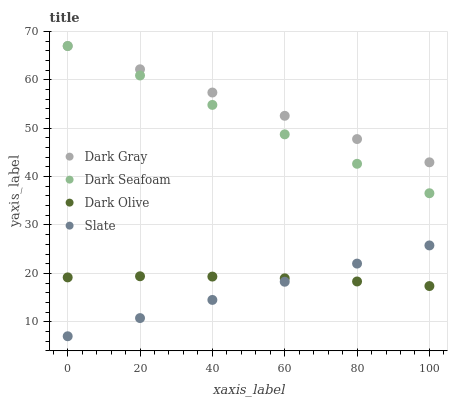Does Slate have the minimum area under the curve?
Answer yes or no. Yes. Does Dark Gray have the maximum area under the curve?
Answer yes or no. Yes. Does Dark Seafoam have the minimum area under the curve?
Answer yes or no. No. Does Dark Seafoam have the maximum area under the curve?
Answer yes or no. No. Is Slate the smoothest?
Answer yes or no. Yes. Is Dark Olive the roughest?
Answer yes or no. Yes. Is Dark Seafoam the smoothest?
Answer yes or no. No. Is Dark Seafoam the roughest?
Answer yes or no. No. Does Slate have the lowest value?
Answer yes or no. Yes. Does Dark Seafoam have the lowest value?
Answer yes or no. No. Does Dark Seafoam have the highest value?
Answer yes or no. Yes. Does Dark Olive have the highest value?
Answer yes or no. No. Is Slate less than Dark Seafoam?
Answer yes or no. Yes. Is Dark Gray greater than Dark Olive?
Answer yes or no. Yes. Does Slate intersect Dark Olive?
Answer yes or no. Yes. Is Slate less than Dark Olive?
Answer yes or no. No. Is Slate greater than Dark Olive?
Answer yes or no. No. Does Slate intersect Dark Seafoam?
Answer yes or no. No. 